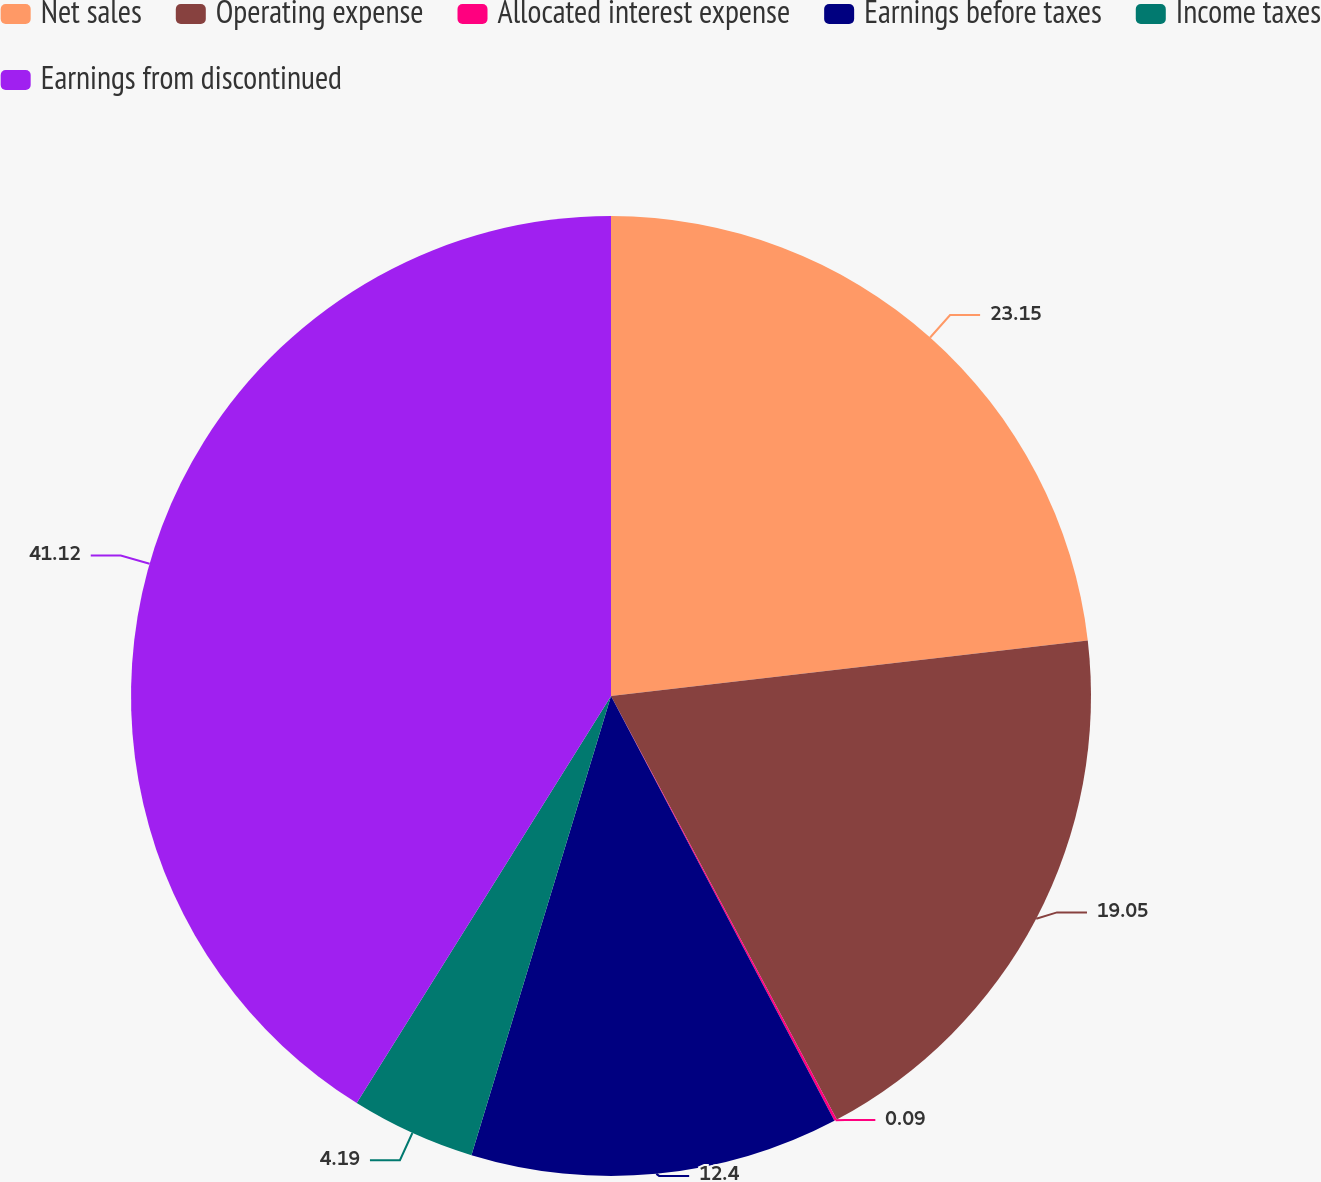Convert chart. <chart><loc_0><loc_0><loc_500><loc_500><pie_chart><fcel>Net sales<fcel>Operating expense<fcel>Allocated interest expense<fcel>Earnings before taxes<fcel>Income taxes<fcel>Earnings from discontinued<nl><fcel>23.15%<fcel>19.05%<fcel>0.09%<fcel>12.4%<fcel>4.19%<fcel>41.11%<nl></chart> 